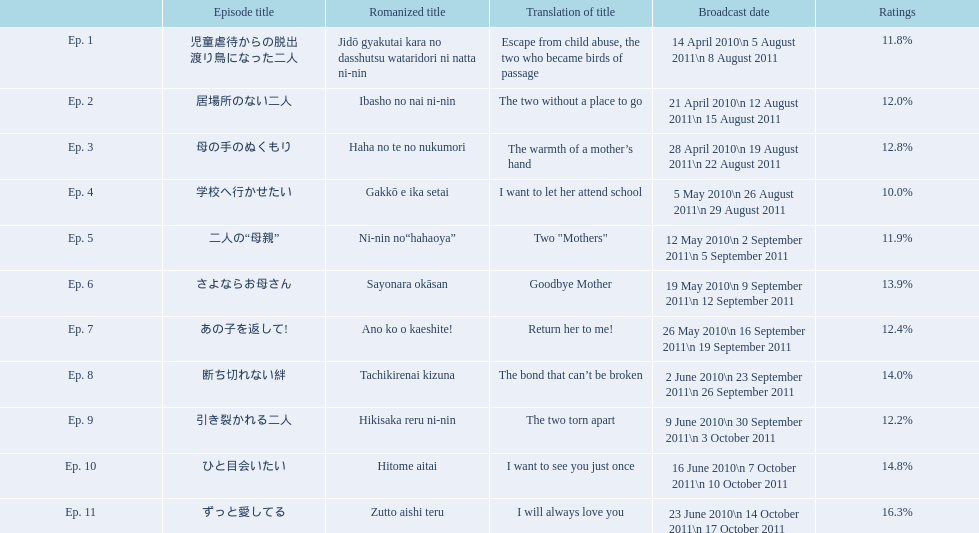What are the installments of mother? 児童虐待からの脱出 渡り鳥になった二人, 居場所のない二人, 母の手のぬくもり, 学校へ行かせたい, 二人の“母親”, さよならお母さん, あの子を返して!, 断ち切れない絆, 引き裂かれる二人, ひと目会いたい, ずっと愛してる. What is the score of episode 10? 14.8%. What is the additional score in the 14 to 15 range? Ep. 8. 